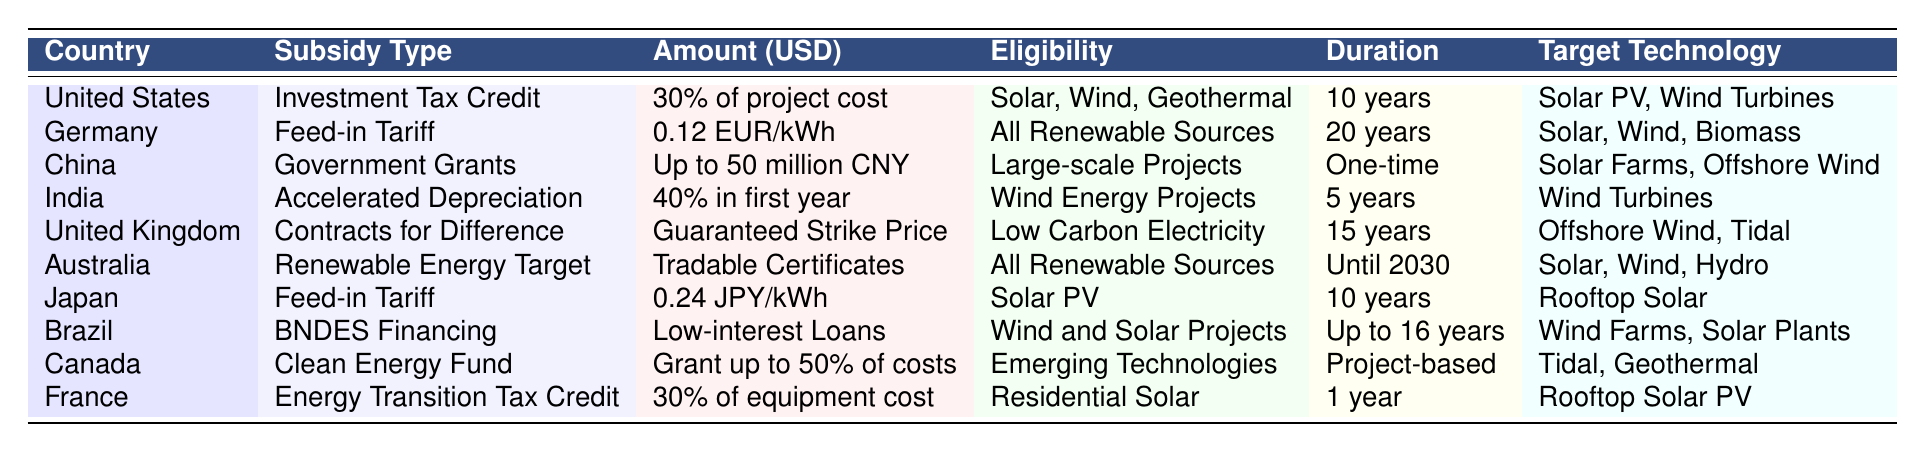What subsidy type is provided by Germany? According to the table, Germany offers a Feed-in Tariff as its subsidy type.
Answer: Feed-in Tariff Which country has the longest duration for subsidies? Germany’s Feed-in Tariff lasts for 20 years, which is the longest duration listed in the table.
Answer: 20 years What percentage of project cost does the United States provide for its Investment Tax Credit? The table indicates that the United States provides 30% of the project cost for its Investment Tax Credit.
Answer: 30% Are all renewable sources eligible for subsidies in Australia? Yes, the table shows that all renewable sources are eligible for Australia's Renewable Energy Target.
Answer: Yes Which country provides a guaranteed strike price as part of their subsidy? The United Kingdom provides a guaranteed strike price through its Contracts for Difference subsidy.
Answer: United Kingdom What is the total percentage of project cost for subsidies from the United States and France combined? The United States provides 30% of project cost and France provides 30% of equipment cost, so combined they contribute 60% of project/equipment costs.
Answer: 60% How many years does India offer accelerated depreciation for wind energy projects? The table states that India offers accelerated depreciation for wind energy projects for a duration of 5 years.
Answer: 5 years Does Canada have a subsidy that allows clients to receive grants for emerging technologies? Yes, the table shows that Canada has the Clean Energy Fund which provides grants up to 50% of costs for emerging technologies.
Answer: Yes Which two target technologies are covered by the subsidy in Brazil? The table specifies that Brazil’s BNDES Financing covers Wind Farms and Solar Plants as target technologies.
Answer: Wind Farms, Solar Plants If an Indian wind energy project costs $1 million, how much can the project owner claim as accelerated depreciation in the first year? Since the accelerated depreciation in India is 40% in the first year, the owner can claim 40% of $1 million, which amounts to $400,000.
Answer: $400,000 